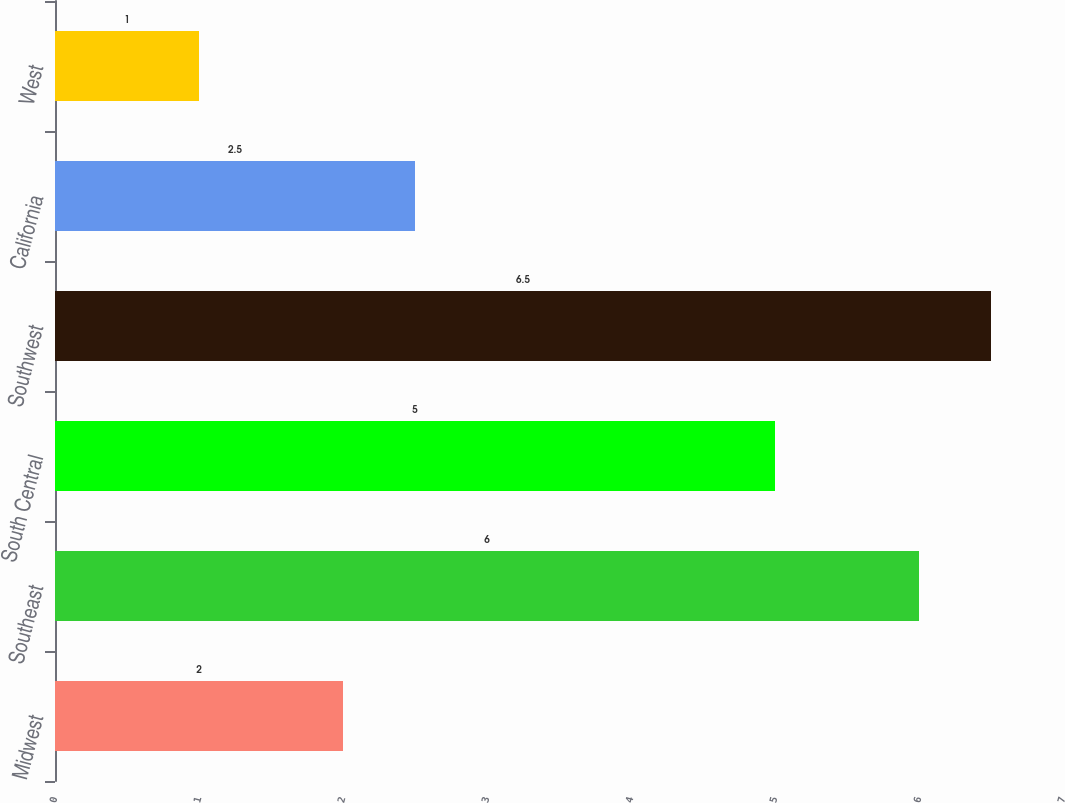<chart> <loc_0><loc_0><loc_500><loc_500><bar_chart><fcel>Midwest<fcel>Southeast<fcel>South Central<fcel>Southwest<fcel>California<fcel>West<nl><fcel>2<fcel>6<fcel>5<fcel>6.5<fcel>2.5<fcel>1<nl></chart> 